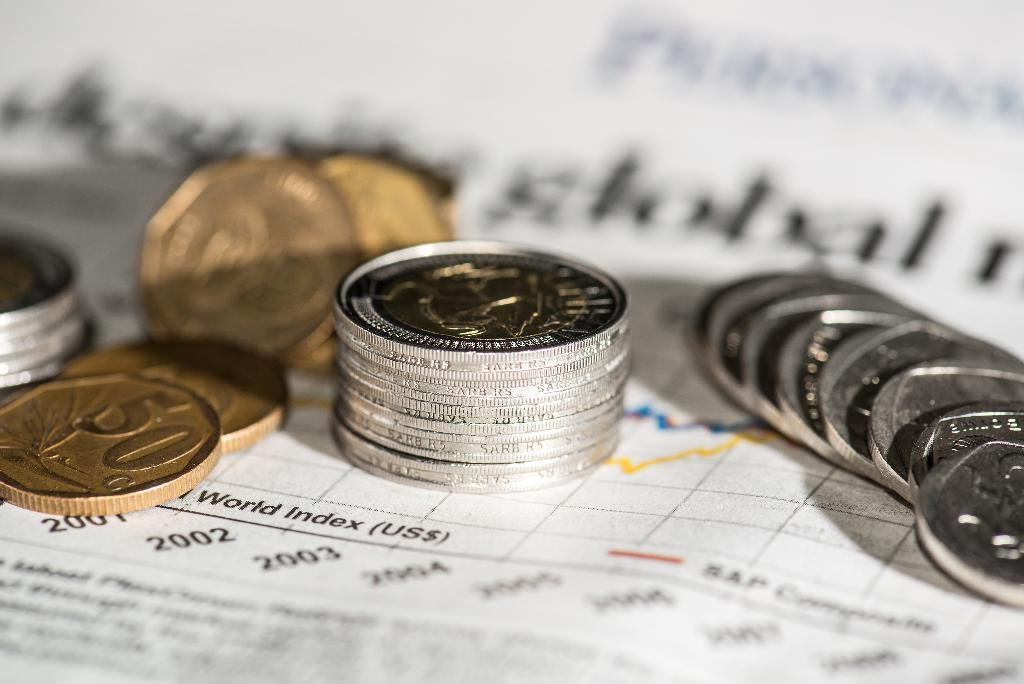Provide a one-sentence caption for the provided image. A stack of gold and silver coins on top of a paper with world index printed on it. 